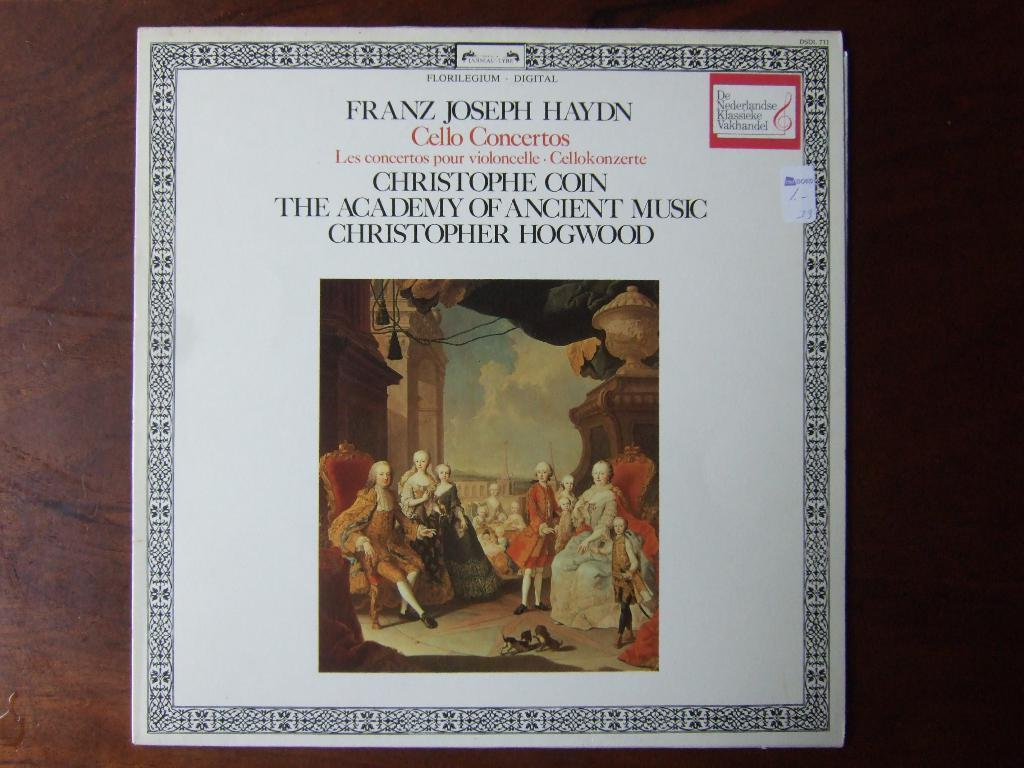<image>
Offer a succinct explanation of the picture presented. The cover of a Franz Joseph Haydn digital recording showcase a drawing of a group of people dressed in Victorian-era clothing. 